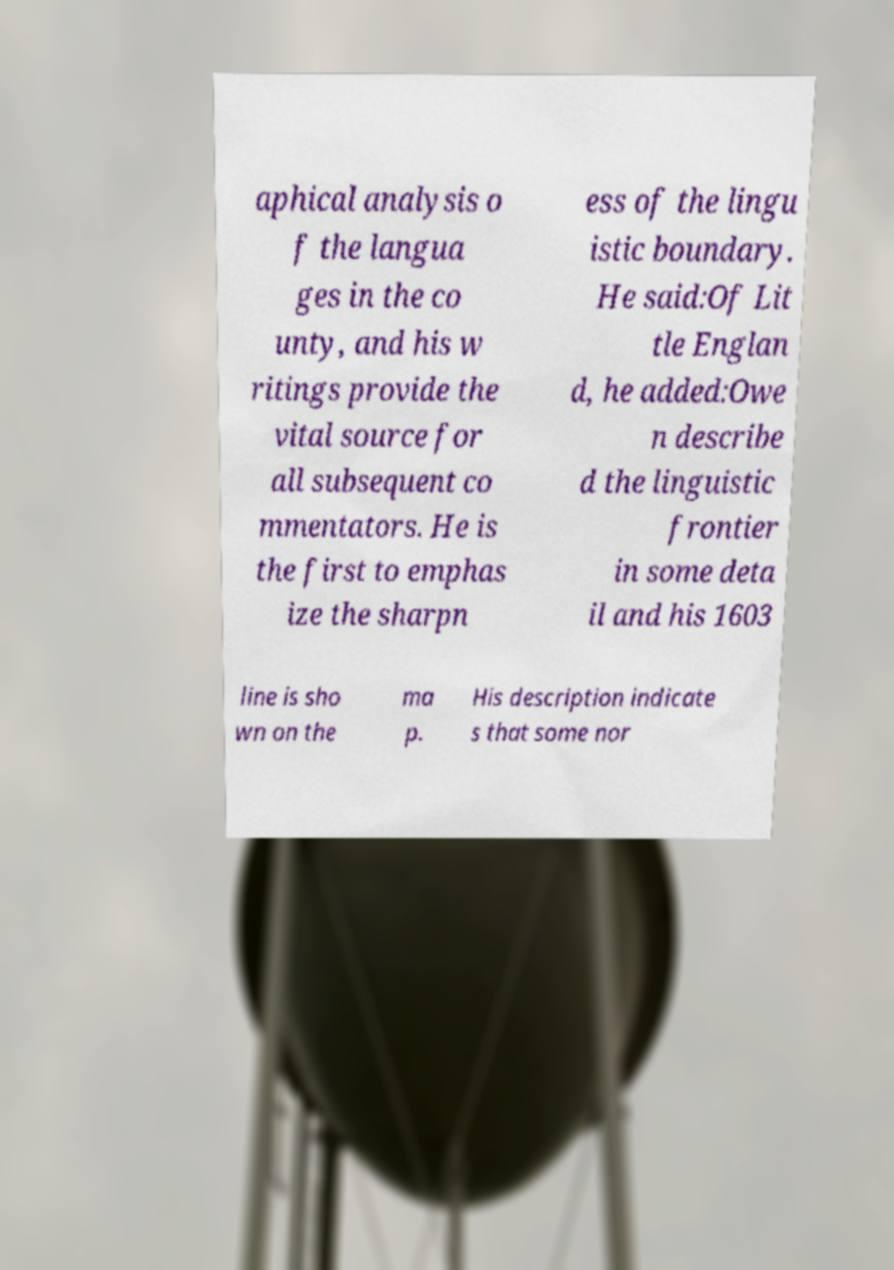I need the written content from this picture converted into text. Can you do that? aphical analysis o f the langua ges in the co unty, and his w ritings provide the vital source for all subsequent co mmentators. He is the first to emphas ize the sharpn ess of the lingu istic boundary. He said:Of Lit tle Englan d, he added:Owe n describe d the linguistic frontier in some deta il and his 1603 line is sho wn on the ma p. His description indicate s that some nor 